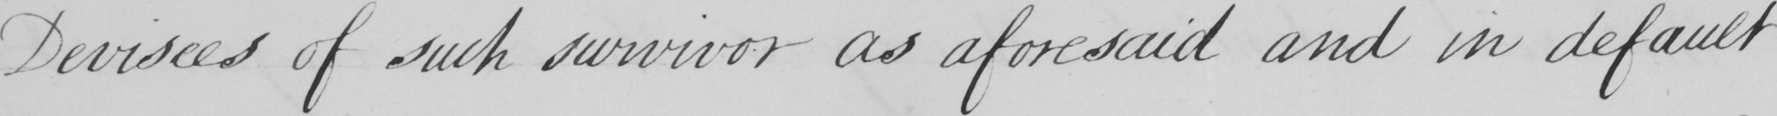Transcribe the text shown in this historical manuscript line. Devisees of such survivor as aforesaid and in default 